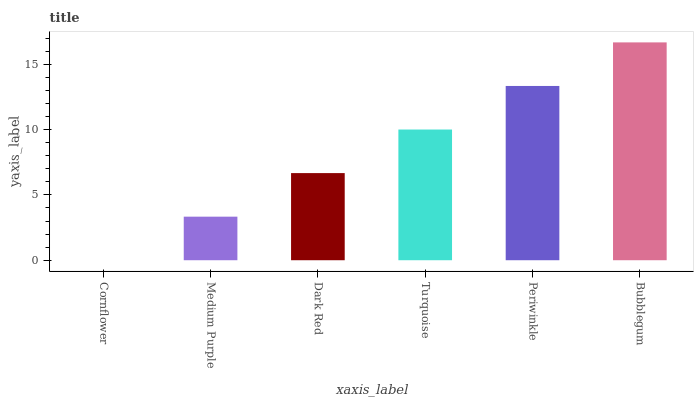Is Cornflower the minimum?
Answer yes or no. Yes. Is Bubblegum the maximum?
Answer yes or no. Yes. Is Medium Purple the minimum?
Answer yes or no. No. Is Medium Purple the maximum?
Answer yes or no. No. Is Medium Purple greater than Cornflower?
Answer yes or no. Yes. Is Cornflower less than Medium Purple?
Answer yes or no. Yes. Is Cornflower greater than Medium Purple?
Answer yes or no. No. Is Medium Purple less than Cornflower?
Answer yes or no. No. Is Turquoise the high median?
Answer yes or no. Yes. Is Dark Red the low median?
Answer yes or no. Yes. Is Medium Purple the high median?
Answer yes or no. No. Is Turquoise the low median?
Answer yes or no. No. 